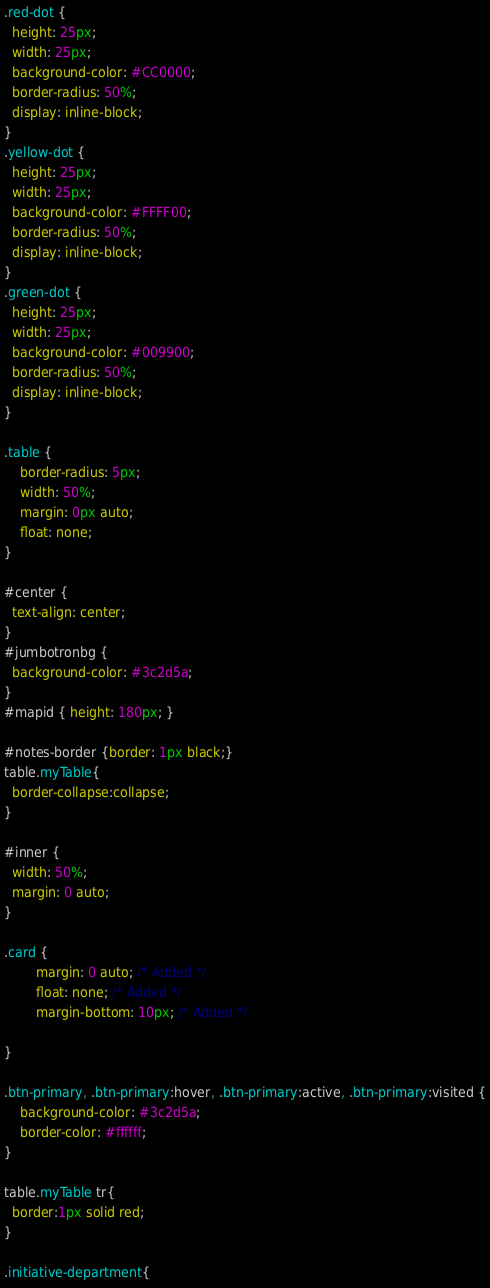<code> <loc_0><loc_0><loc_500><loc_500><_CSS_>.red-dot {
  height: 25px;
  width: 25px;
  background-color: #CC0000;
  border-radius: 50%;
  display: inline-block;
}
.yellow-dot {
  height: 25px;
  width: 25px;
  background-color: #FFFF00;
  border-radius: 50%;
  display: inline-block;
}
.green-dot {
  height: 25px;
  width: 25px;
  background-color: #009900;
  border-radius: 50%;
  display: inline-block;
}

.table {
    border-radius: 5px;
    width: 50%;
    margin: 0px auto;
    float: none;
}

#center {
  text-align: center;
}
#jumbotronbg {
  background-color: #3c2d5a;
}
#mapid { height: 180px; }

#notes-border {border: 1px black;}
table.myTable{
  border-collapse:collapse;
}

#inner {
  width: 50%;
  margin: 0 auto;
}

.card {
        margin: 0 auto; /* Added */
        float: none; /* Added */
        margin-bottom: 10px; /* Added */
        
}

.btn-primary, .btn-primary:hover, .btn-primary:active, .btn-primary:visited {
    background-color: #3c2d5a;
    border-color: #ffffff;
}

table.myTable tr{
  border:1px solid red;
}

.initiative-department{</code> 